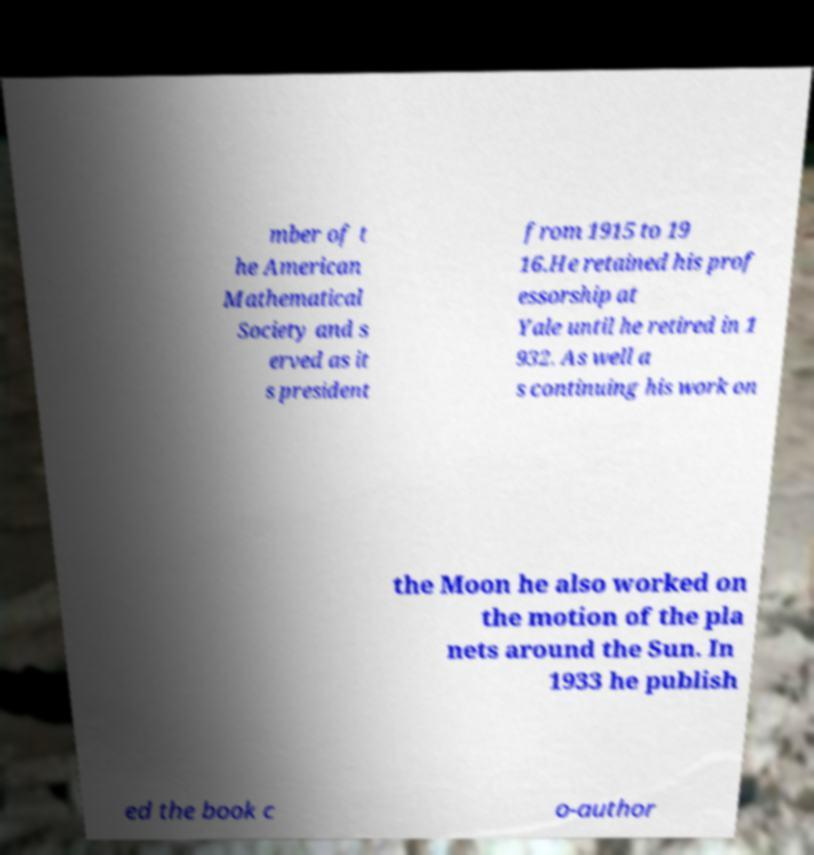Can you read and provide the text displayed in the image?This photo seems to have some interesting text. Can you extract and type it out for me? mber of t he American Mathematical Society and s erved as it s president from 1915 to 19 16.He retained his prof essorship at Yale until he retired in 1 932. As well a s continuing his work on the Moon he also worked on the motion of the pla nets around the Sun. In 1933 he publish ed the book c o-author 